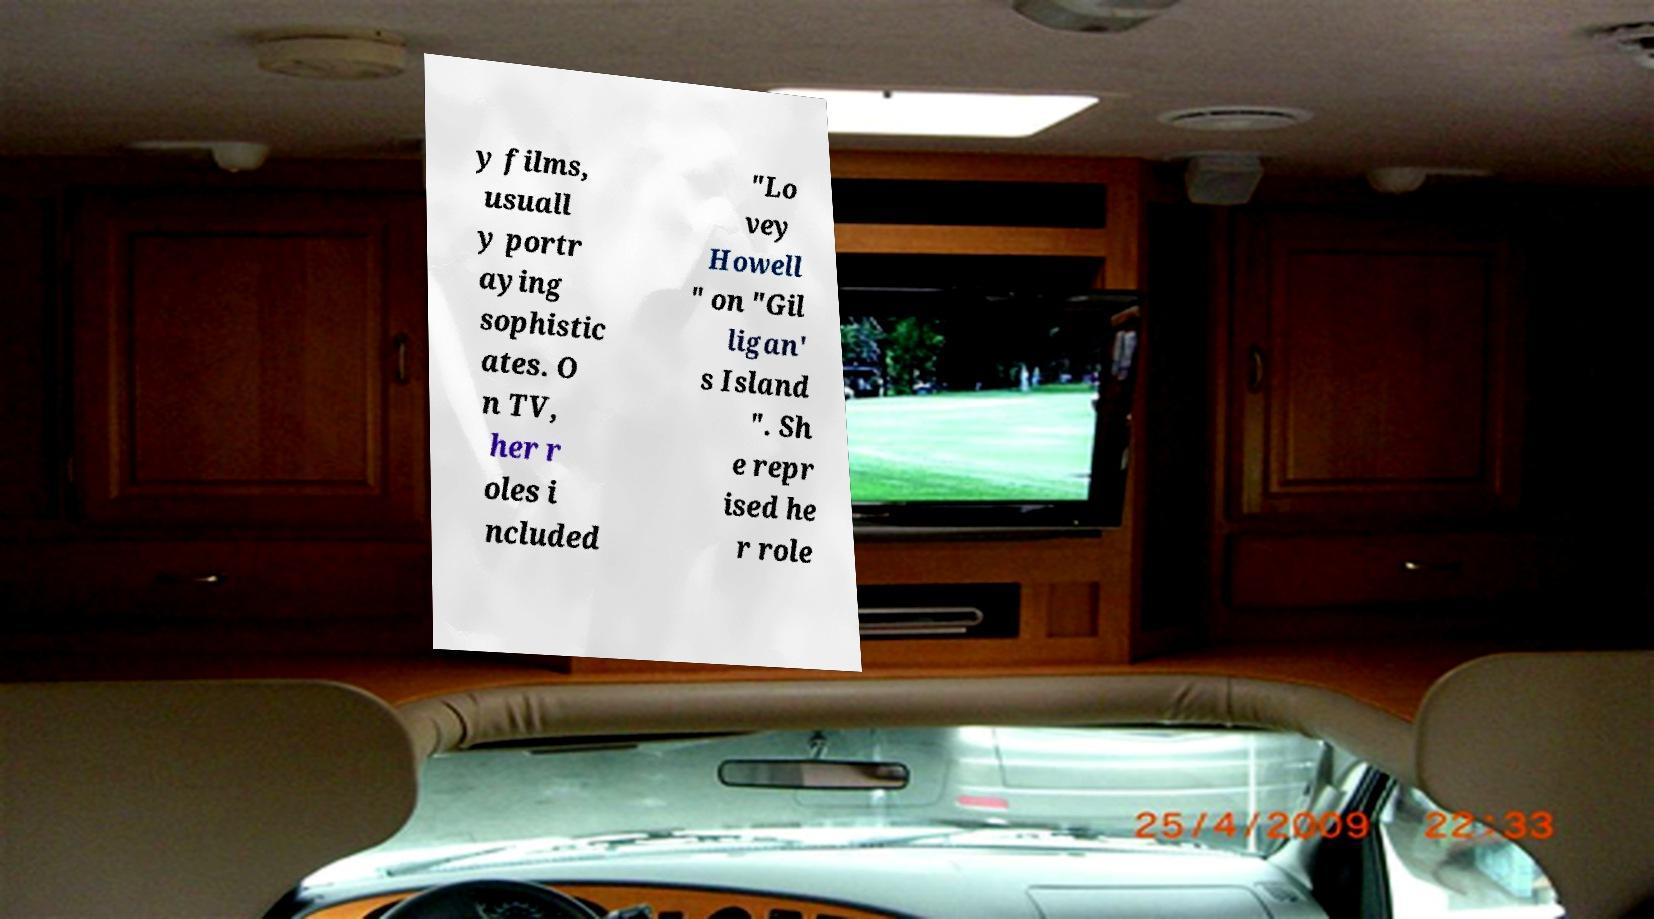Can you accurately transcribe the text from the provided image for me? y films, usuall y portr aying sophistic ates. O n TV, her r oles i ncluded "Lo vey Howell " on "Gil ligan' s Island ". Sh e repr ised he r role 